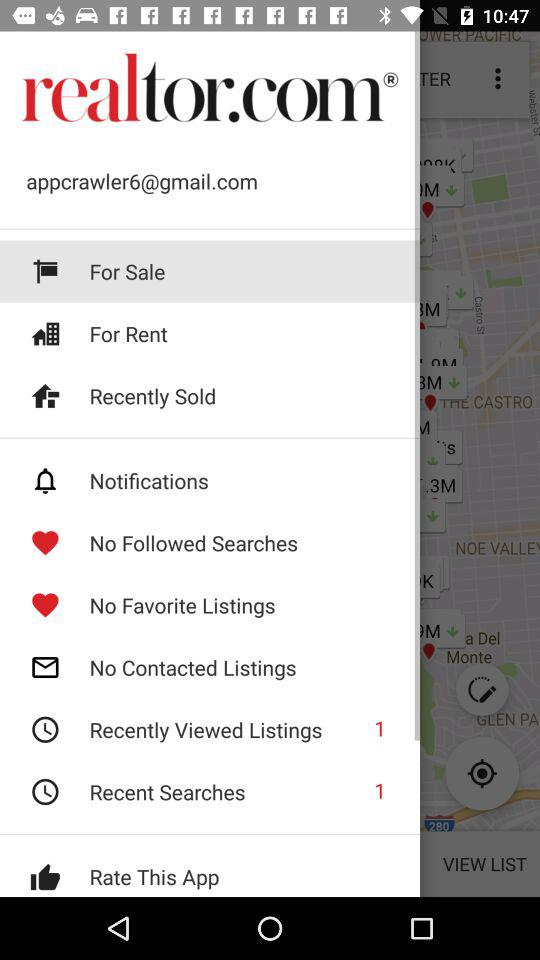What is the number of items in "Recent Searches"? The number of items in "Recent Searches" is 1. 